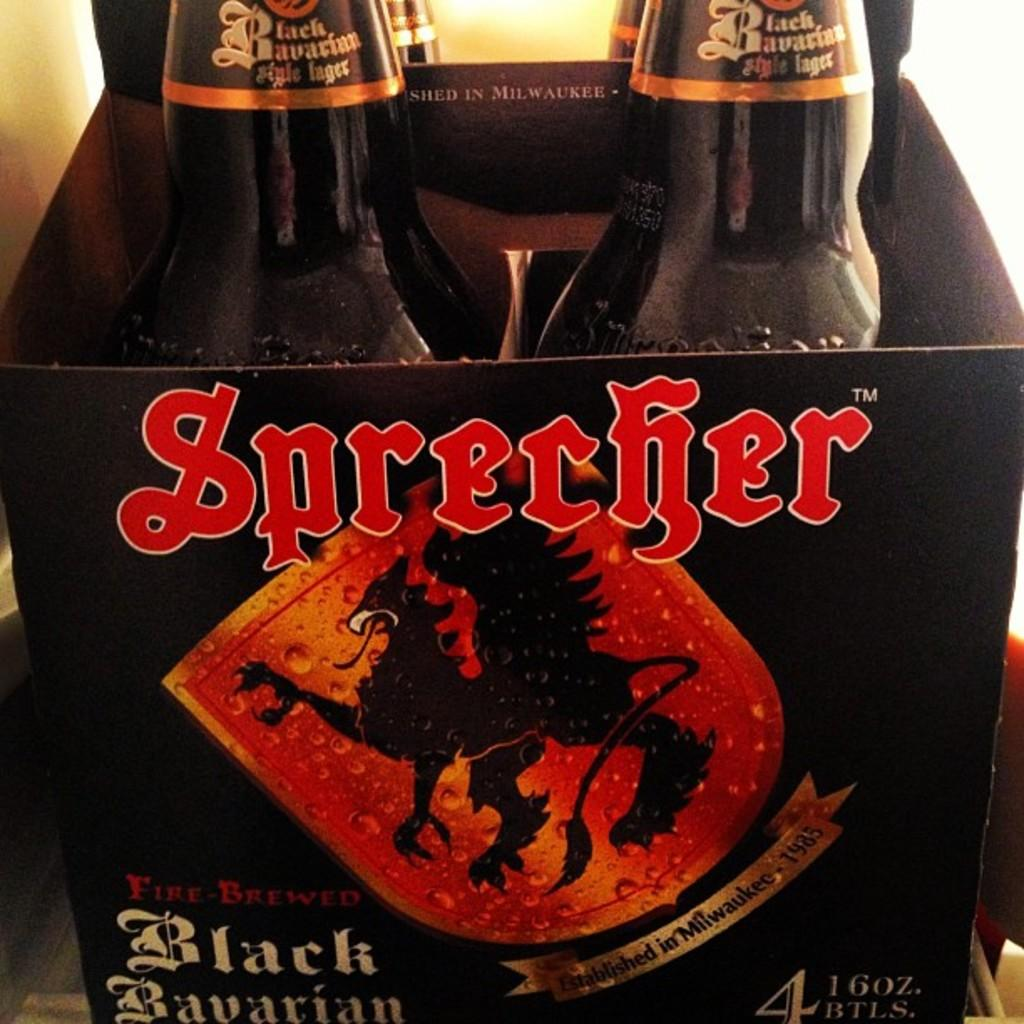<image>
Give a short and clear explanation of the subsequent image. Four 16 oz beers in a box from Sprecher. 